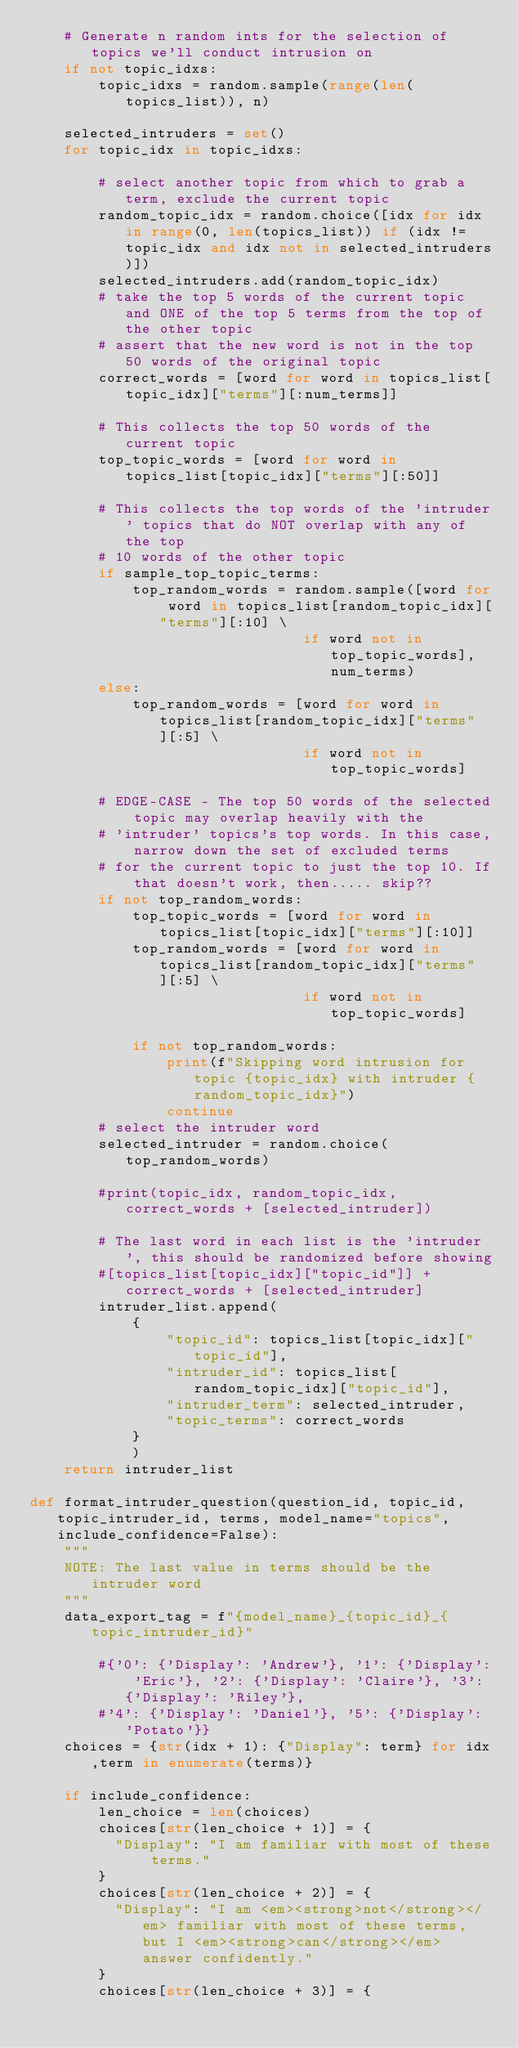<code> <loc_0><loc_0><loc_500><loc_500><_Python_>    # Generate n random ints for the selection of topics we'll conduct intrusion on
    if not topic_idxs:
        topic_idxs = random.sample(range(len(topics_list)), n)
        
    selected_intruders = set()
    for topic_idx in topic_idxs:
        
        # select another topic from which to grab a term, exclude the current topic
        random_topic_idx = random.choice([idx for idx in range(0, len(topics_list)) if (idx != topic_idx and idx not in selected_intruders)])
        selected_intruders.add(random_topic_idx)
        # take the top 5 words of the current topic and ONE of the top 5 terms from the top of the other topic
        # assert that the new word is not in the top 50 words of the original topic
        correct_words = [word for word in topics_list[topic_idx]["terms"][:num_terms]]
        
        # This collects the top 50 words of the current topic
        top_topic_words = [word for word in topics_list[topic_idx]["terms"][:50]]

        # This collects the top words of the 'intruder' topics that do NOT overlap with any of the top
        # 10 words of the other topic
        if sample_top_topic_terms:
            top_random_words = random.sample([word for word in topics_list[random_topic_idx]["terms"][:10] \
                                if word not in top_topic_words], num_terms)
        else:
            top_random_words = [word for word in topics_list[random_topic_idx]["terms"][:5] \
                                if word not in top_topic_words]
        
        # EDGE-CASE - The top 50 words of the selected topic may overlap heavily with the
        # 'intruder' topics's top words. In this case, narrow down the set of excluded terms
        # for the current topic to just the top 10. If that doesn't work, then..... skip??
        if not top_random_words:
            top_topic_words = [word for word in topics_list[topic_idx]["terms"][:10]]
            top_random_words = [word for word in topics_list[random_topic_idx]["terms"][:5] \
                                if word not in top_topic_words]
        
            if not top_random_words:
                print(f"Skipping word intrusion for topic {topic_idx} with intruder {random_topic_idx}")
                continue
        # select the intruder word
        selected_intruder = random.choice(top_random_words)
        
        #print(topic_idx, random_topic_idx, correct_words + [selected_intruder])
        
        # The last word in each list is the 'intruder', this should be randomized before showing
        #[topics_list[topic_idx]["topic_id"]] + correct_words + [selected_intruder]
        intruder_list.append(
            {
                "topic_id": topics_list[topic_idx]["topic_id"],
                "intruder_id": topics_list[random_topic_idx]["topic_id"],
                "intruder_term": selected_intruder,
                "topic_terms": correct_words
            }
            )
    return intruder_list

def format_intruder_question(question_id, topic_id, topic_intruder_id, terms, model_name="topics", include_confidence=False):
    """
    NOTE: The last value in terms should be the intruder word
    """
    data_export_tag = f"{model_name}_{topic_id}_{topic_intruder_id}"

        #{'0': {'Display': 'Andrew'}, '1': {'Display': 'Eric'}, '2': {'Display': 'Claire'}, '3': {'Display': 'Riley'},
        #'4': {'Display': 'Daniel'}, '5': {'Display': 'Potato'}}
    choices = {str(idx + 1): {"Display": term} for idx,term in enumerate(terms)}

    if include_confidence:
        len_choice = len(choices)
        choices[str(len_choice + 1)] = {
          "Display": "I am familiar with most of these terms."
        }
        choices[str(len_choice + 2)] = {
          "Display": "I am <em><strong>not</strong></em> familiar with most of these terms, but I <em><strong>can</strong></em> answer confidently."
        }
        choices[str(len_choice + 3)] = {</code> 